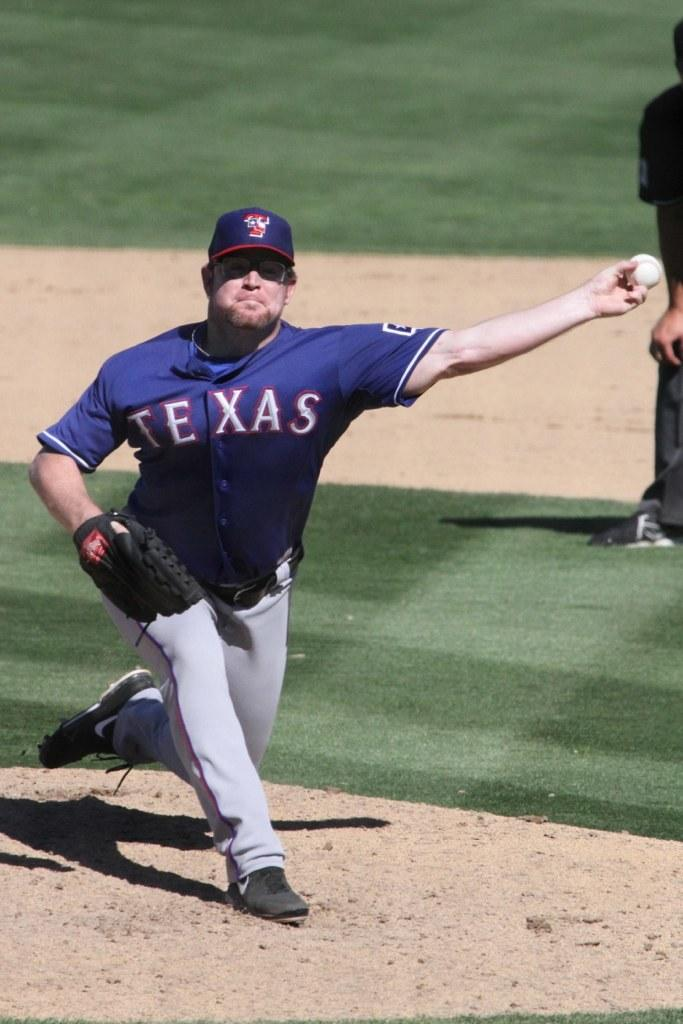<image>
Write a terse but informative summary of the picture. pitcher for texas throwing the ball and partial image of man bent over behind him 